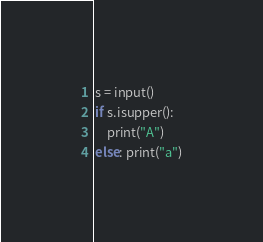<code> <loc_0><loc_0><loc_500><loc_500><_Python_>s = input()
if s.isupper():
    print("A")
else: print("a")</code> 